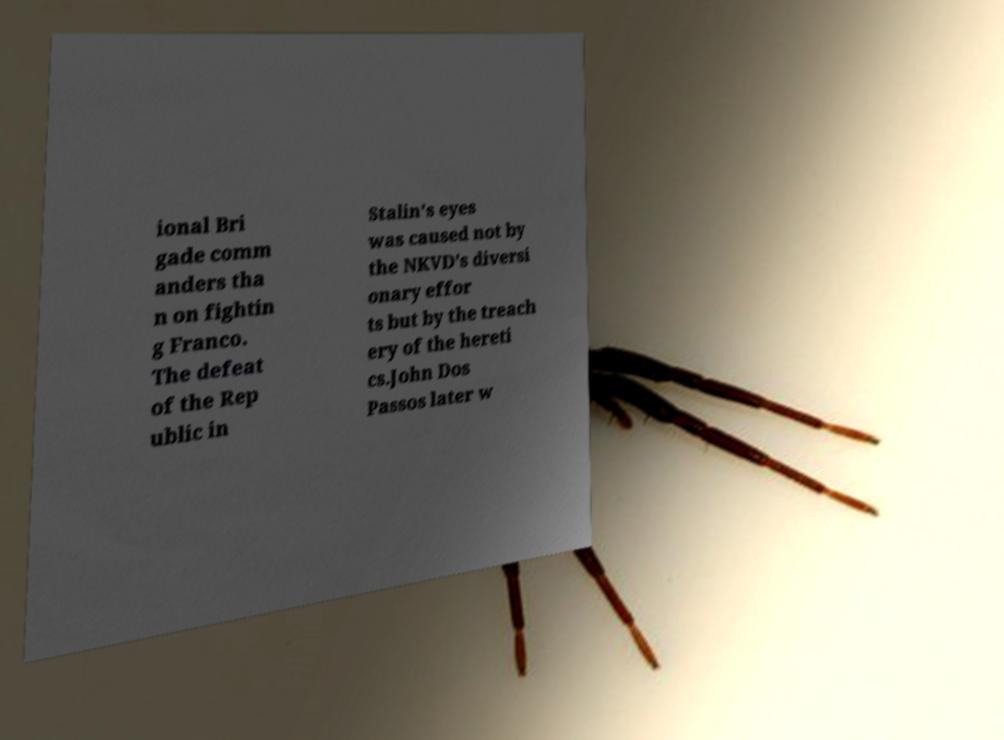Can you accurately transcribe the text from the provided image for me? ional Bri gade comm anders tha n on fightin g Franco. The defeat of the Rep ublic in Stalin's eyes was caused not by the NKVD's diversi onary effor ts but by the treach ery of the hereti cs.John Dos Passos later w 